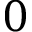<formula> <loc_0><loc_0><loc_500><loc_500>0</formula> 